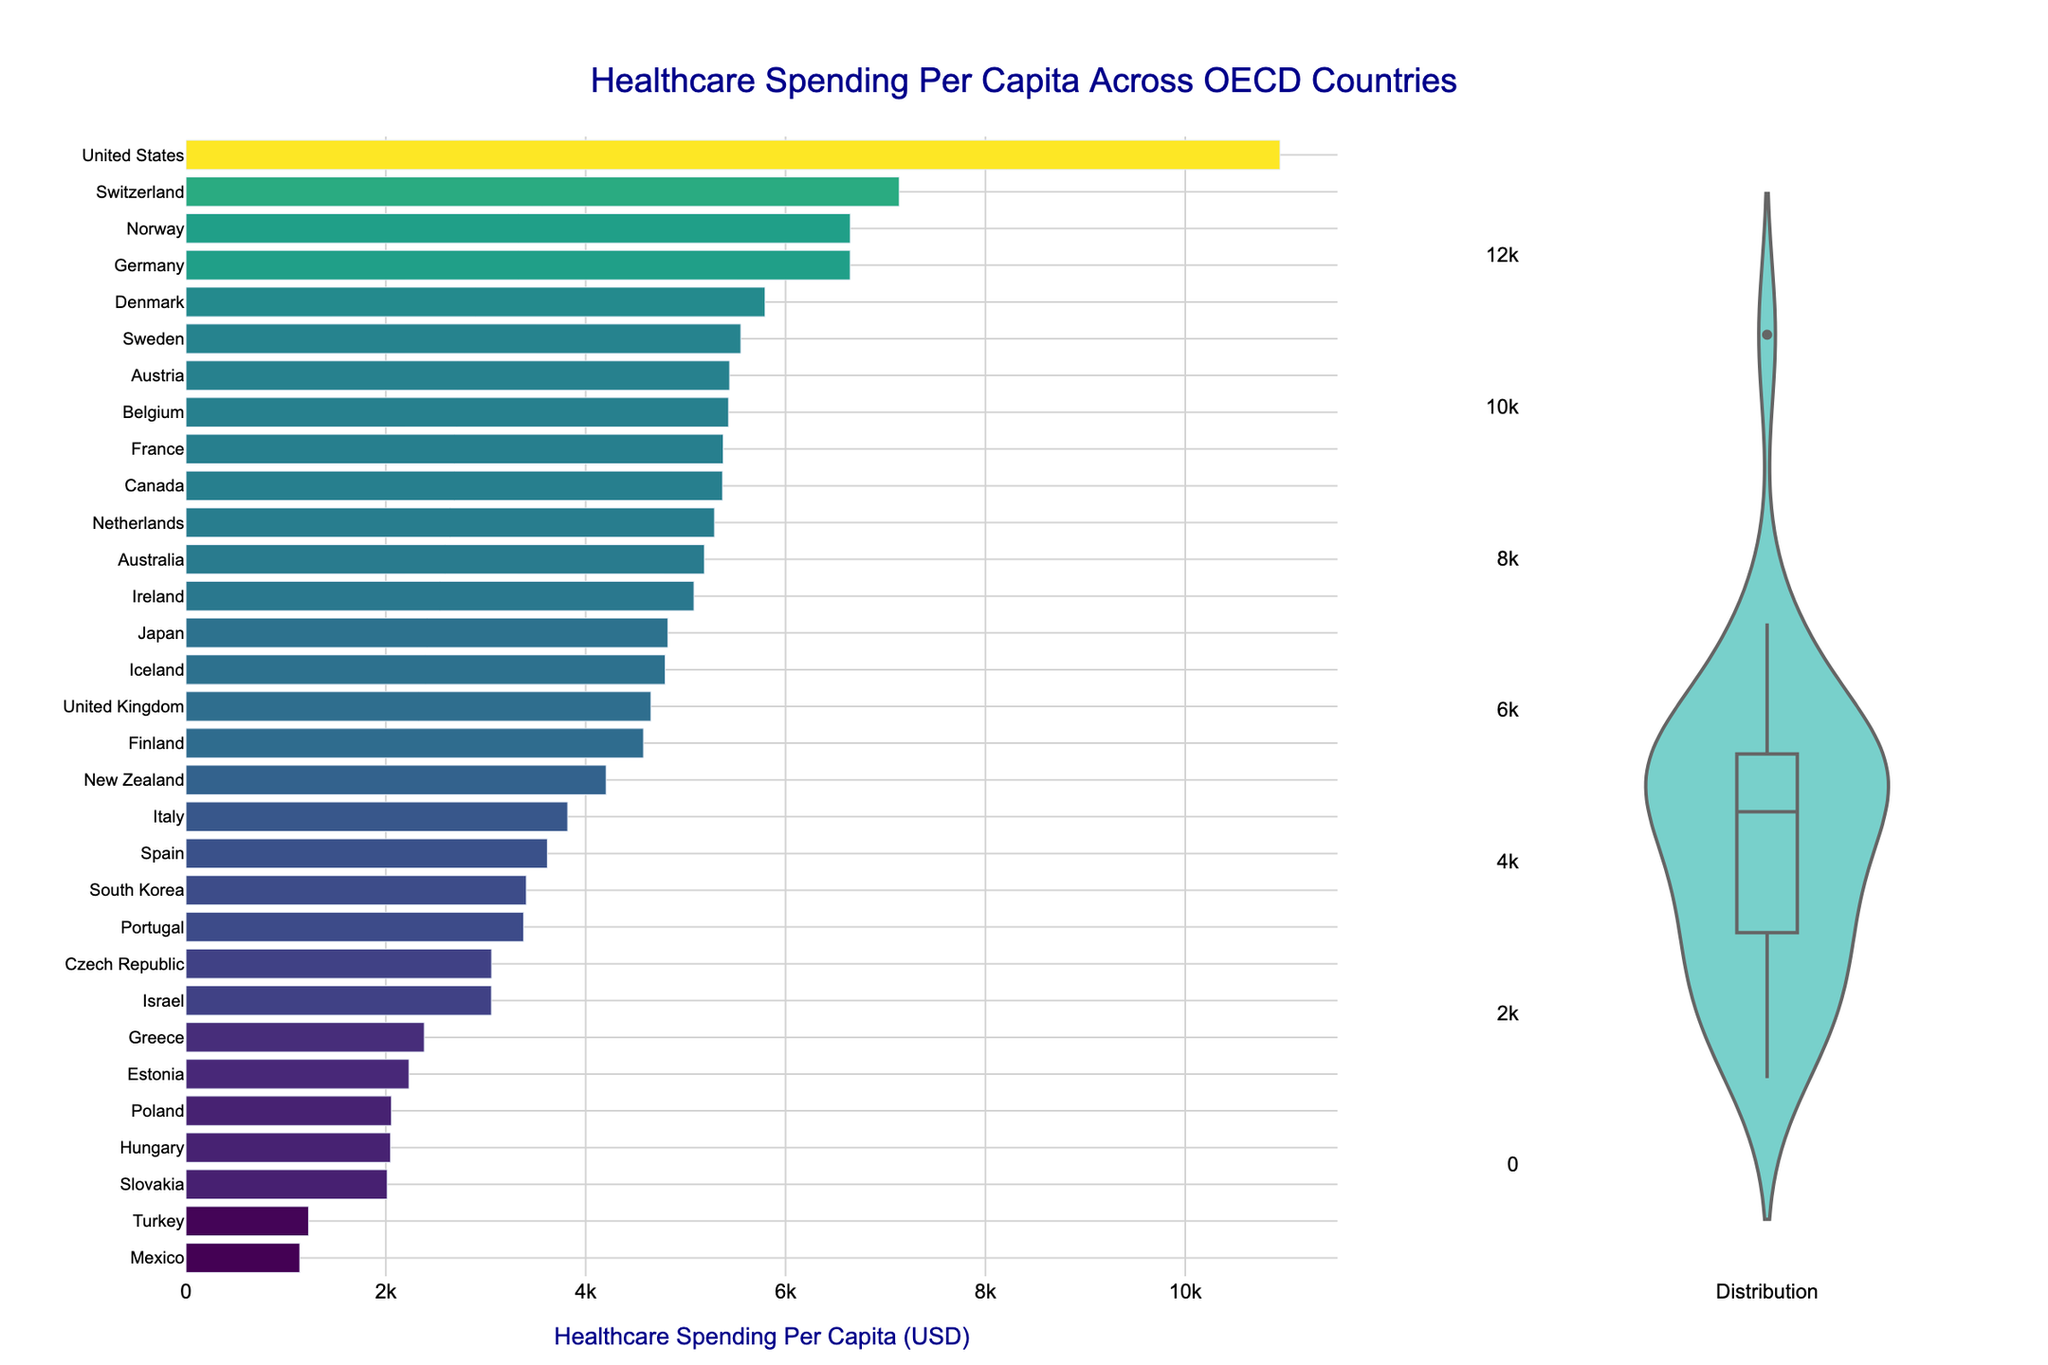What is the title of the plot? The title is prominently placed at the top of the plot and can be read directly.
Answer: Healthcare Spending Per Capita Across OECD Countries Which country has the highest healthcare spending per capita according to the bar plot? The highest bar represents the country with the highest spending, which is labeled as the United States.
Answer: United States What is the healthcare spending per capita for Finland? Locate Finland in the bar plot and refer to the corresponding value on the x-axis.
Answer: 4578 USD How many countries have healthcare spending per capita above 5000 USD? Count the bars on the left side of the x-axis that extend beyond the 5000 USD mark.
Answer: 10 countries Which country spends less on healthcare per capita: Greece or Hungary? Compare the heights of the bars for Greece and Hungary. Greece has a higher bar compared to Hungary.
Answer: Hungary What is the median healthcare spending per capita across OECD countries based on the violin plot? The median is represented by the middle line in the box inside the violin plot.
Answer: Around 4570 USD Compare the healthcare spending per capita of Canada and the United Kingdom? Which one is higher? Look at the positions of the bars for Canada and the United Kingdom in the bar plot. The bar for Canada is higher.
Answer: Canada What is the range of healthcare spending per capita in OECD countries? Identify the lowest and highest x-values in the bar plot to find the range. The lowest spending is around 1138 USD (Mexico) and the highest is 10948 USD (United States). The range is 10948 - 1138.
Answer: 9810 USD Which country has the closest healthcare spending per capita to the median? Refer to the countries around the median line in the violin plot and identify the closest.
Answer: Finland (4578 USD) Are there any visible outliers in the healthcare spending data? Check for data points that deviate significantly from the rest in the violin plot. The United States appears as an outlier due to its much higher spending.
Answer: Yes, United States 